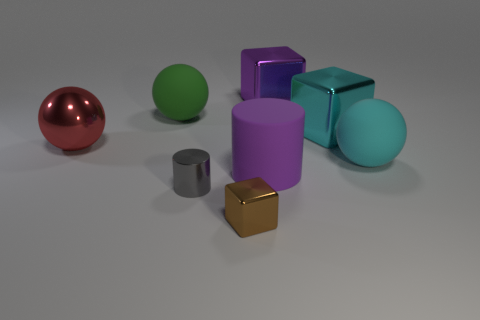Subtract all purple metal blocks. How many blocks are left? 2 Subtract all brown cubes. How many cubes are left? 2 Subtract all cylinders. How many objects are left? 6 Subtract 2 cubes. How many cubes are left? 1 Subtract all yellow cylinders. How many brown blocks are left? 1 Subtract all tiny red spheres. Subtract all tiny gray metallic objects. How many objects are left? 7 Add 8 big red objects. How many big red objects are left? 9 Add 1 small purple balls. How many small purple balls exist? 1 Add 2 large purple cylinders. How many objects exist? 10 Subtract 1 cyan cubes. How many objects are left? 7 